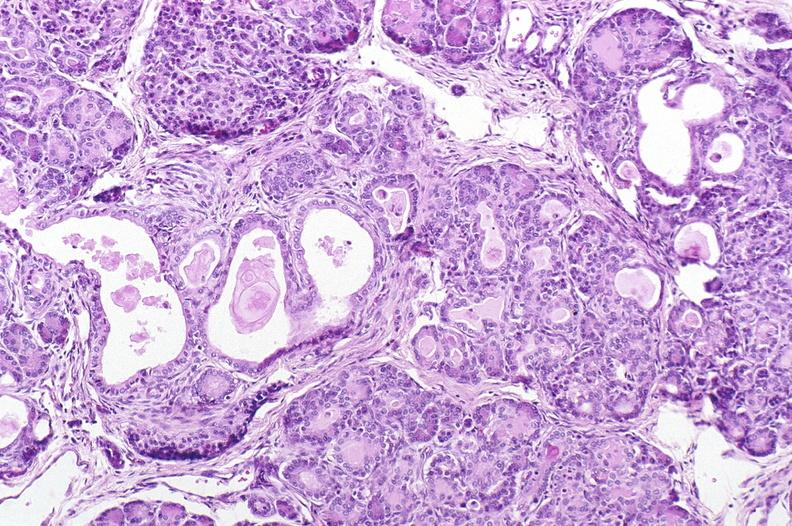does this image show cystic fibrosis?
Answer the question using a single word or phrase. Yes 